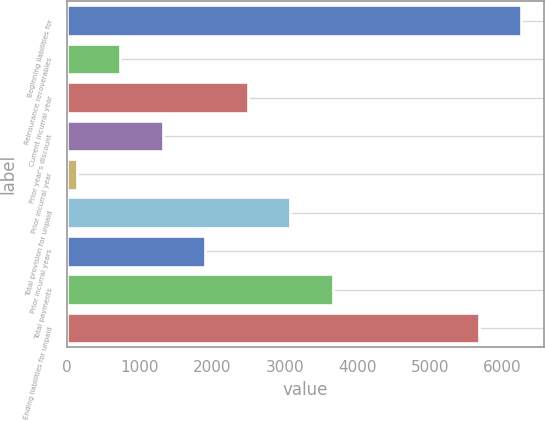Convert chart. <chart><loc_0><loc_0><loc_500><loc_500><bar_chart><fcel>Beginning liabilities for<fcel>Reinsurance recoverables<fcel>Current incurral year<fcel>Prior year's discount<fcel>Prior incurral year<fcel>Total provision for unpaid<fcel>Prior incurral years<fcel>Total payments<fcel>Ending liabilities for unpaid<nl><fcel>6257.7<fcel>732.7<fcel>2492.8<fcel>1319.4<fcel>146<fcel>3079.5<fcel>1906.1<fcel>3666.2<fcel>5671<nl></chart> 